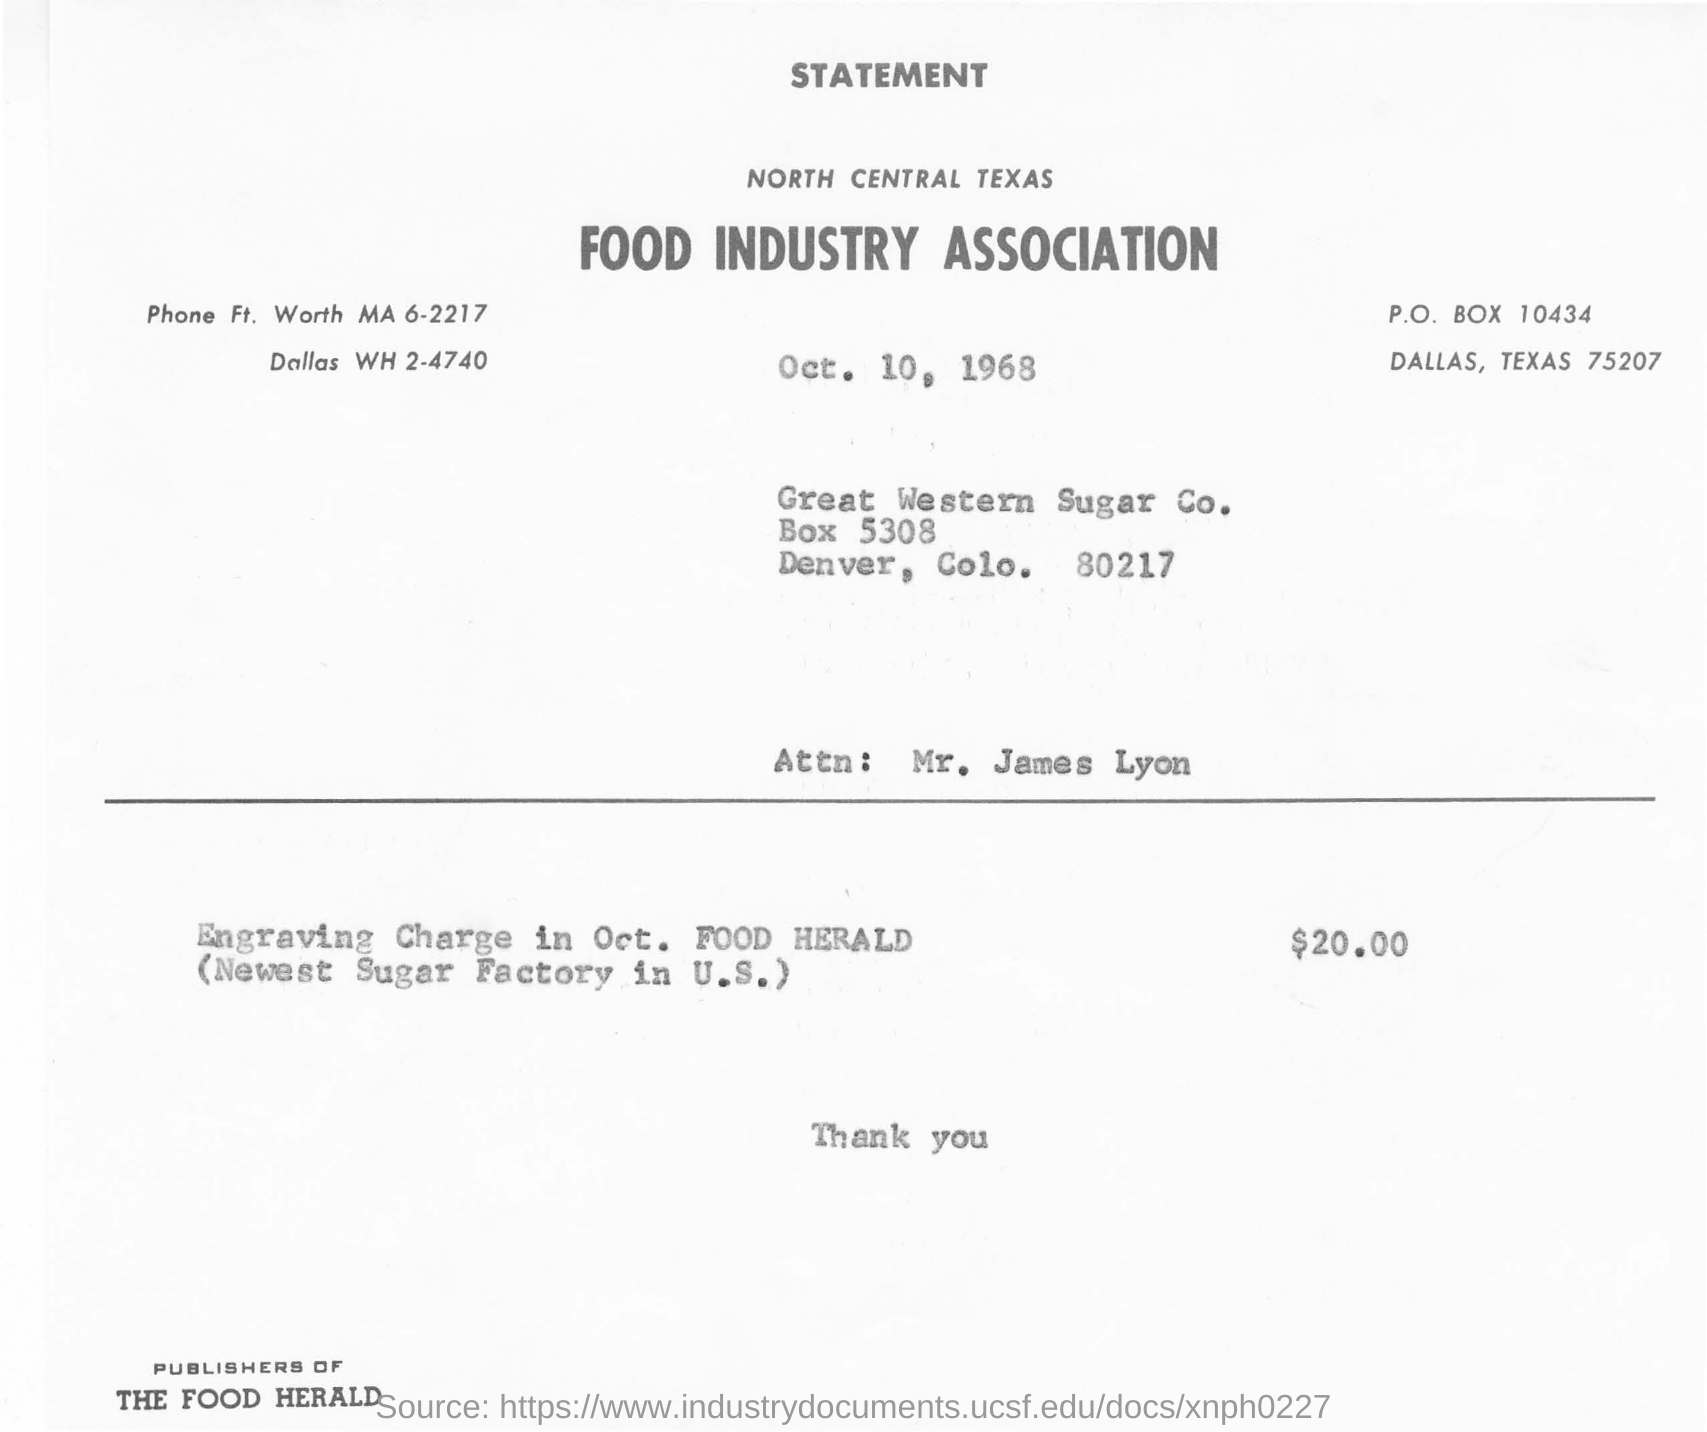What is the name of association in statement?
Provide a succinct answer. Food industry association. What is the post box number for dallas, texas ?
Make the answer very short. 10434. In which zone of texas food industry association is located?
Provide a short and direct response. NORTH CENTRAL. What is the date mentioned int statement?
Your response must be concise. Oct. 10, 1968. Whose name in the attention?
Offer a terse response. Mr. James Lyon. How much amount of money for the engraving charge in oct. food herald?
Offer a very short reply. $20.00. Who is the publisher ?
Your answer should be very brief. THE FOOD HERALD. 